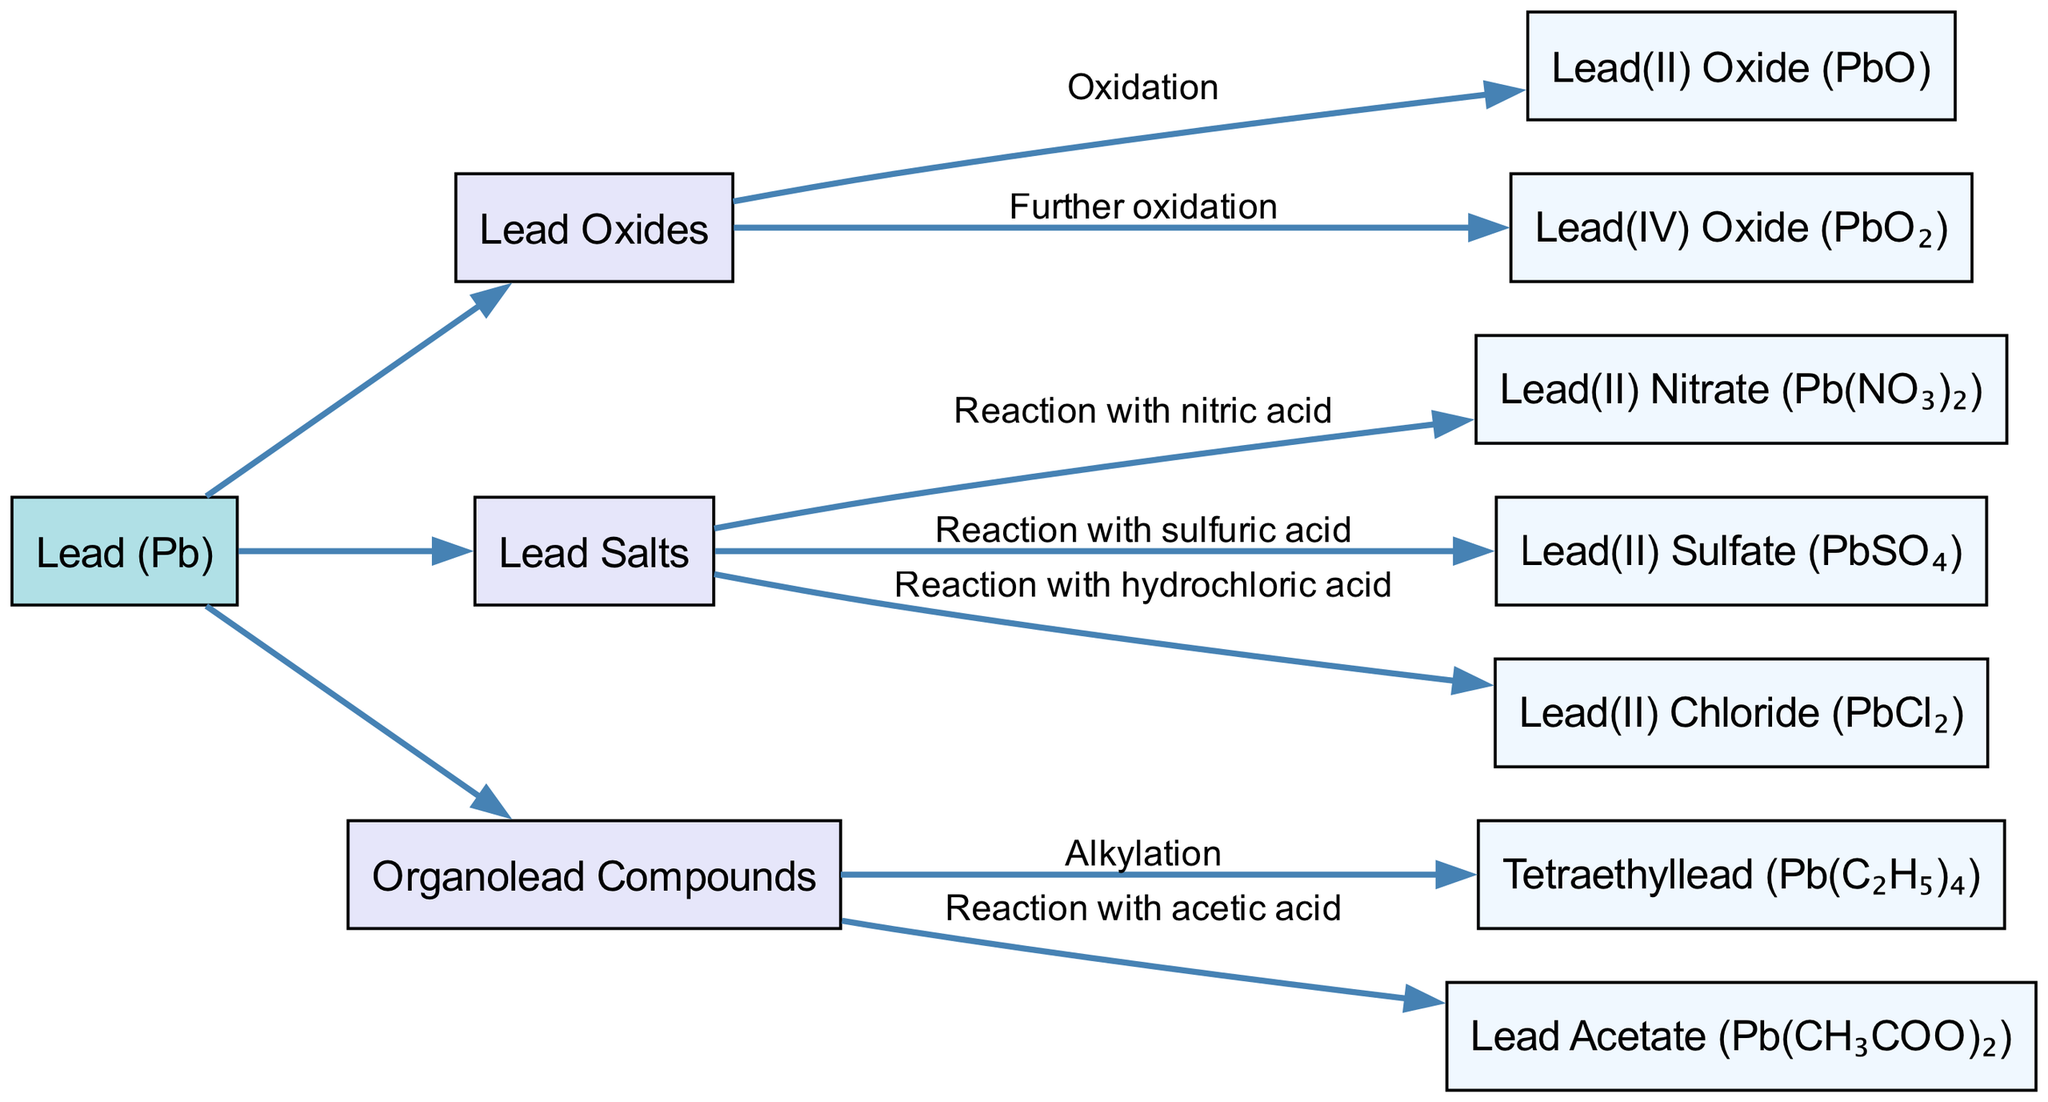What is the root compound in the family tree? The diagram indicates that "Lead (Pb)" is at the topmost position and serves as the starting point for the family tree, making it the root compound.
Answer: Lead (Pb) How many main categories are in the family tree? The family tree has three primary categories under the root compound: "Lead Oxides," "Lead Salts," and "Organolead Compounds." Therefore, the count of these categories is three.
Answer: 3 What transformation occurs to create Lead(IV) Oxide? The diagram shows that Lead(IV) Oxide (PbO₂) is produced from Lead(II) Oxide (PbO) through the process of "Further oxidation." This indicates that it undergoes oxidation beyond Lead(II) Oxide.
Answer: Further oxidation Which lead salt is produced by reacting with hydrochloric acid? In the "Lead Salts" category, the diagram specifies that Lead(II) Chloride (PbCl₂) is generated via the reaction with hydrochloric acid. This directly identifies the compound associated with that specific reaction.
Answer: Lead(II) Chloride (PbCl₂) What are the two organolead compounds listed? The "Organolead Compounds" section of the diagram includes Tetraethyllead (Pb(C₂H₅)₄) and Lead Acetate (Pb(CH₃COO)₂). These represent the full set of organolead compounds displayed.
Answer: Tetraethyllead, Lead Acetate What transformation does Lead(II) Nitrate undergo? According to the diagram, Lead(II) Nitrate (Pb(NO₃)₂) is created from a reaction with nitric acid. This transformation is indicated along the edge connecting Lead(II) Nitrate to its precursor.
Answer: Reaction with nitric acid Which lead compound is formed by alkylation? The transformation of "Alkylation" leads to the formation of Tetraethyllead (Pb(C₂H₅)₄), which is specified as an organolead compound in the diagram. This means that this specific compound arises from the alkylation process.
Answer: Tetraethyllead (Pb(C₂H₅)₄) What is the relationship between Lead Oxides and the transformation to Lead(II) Oxide? Lead Oxides is a direct category under which Lead(II) Oxide (PbO) is listed, linked by the transformation of "Oxidation." This shows the relationship, indicating that Lead(II) Oxide is formed from Lead Oxides through oxidation.
Answer: Oxidation 